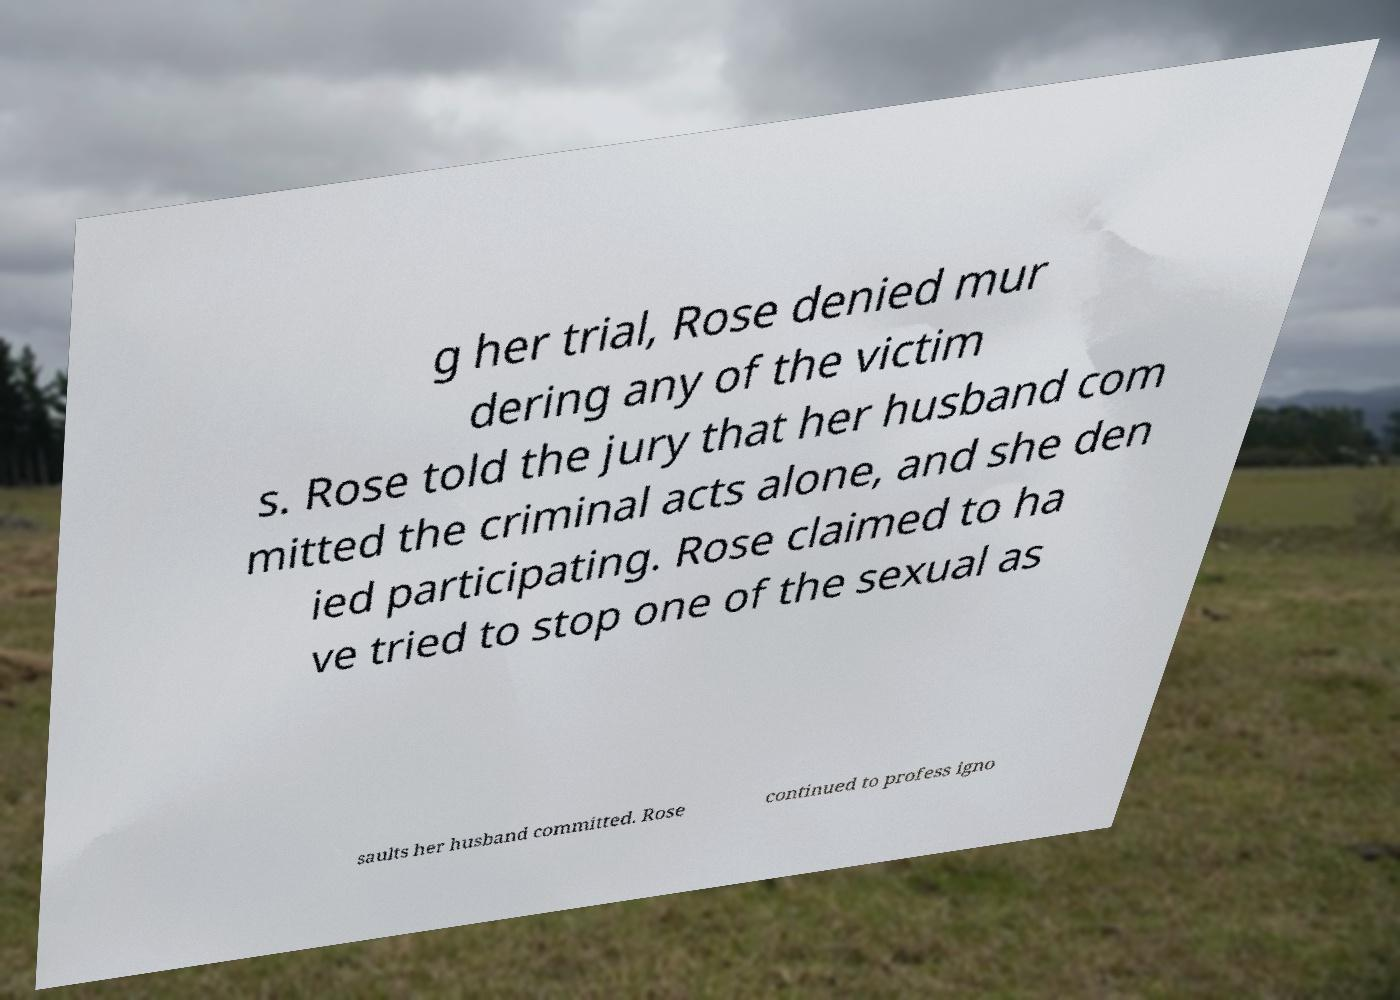Could you extract and type out the text from this image? g her trial, Rose denied mur dering any of the victim s. Rose told the jury that her husband com mitted the criminal acts alone, and she den ied participating. Rose claimed to ha ve tried to stop one of the sexual as saults her husband committed. Rose continued to profess igno 